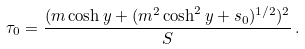<formula> <loc_0><loc_0><loc_500><loc_500>\tau _ { 0 } = \frac { ( m \cosh y + ( m ^ { 2 } \cosh ^ { 2 } y + s _ { 0 } ) ^ { 1 / 2 } ) ^ { 2 } } { S } \, .</formula> 